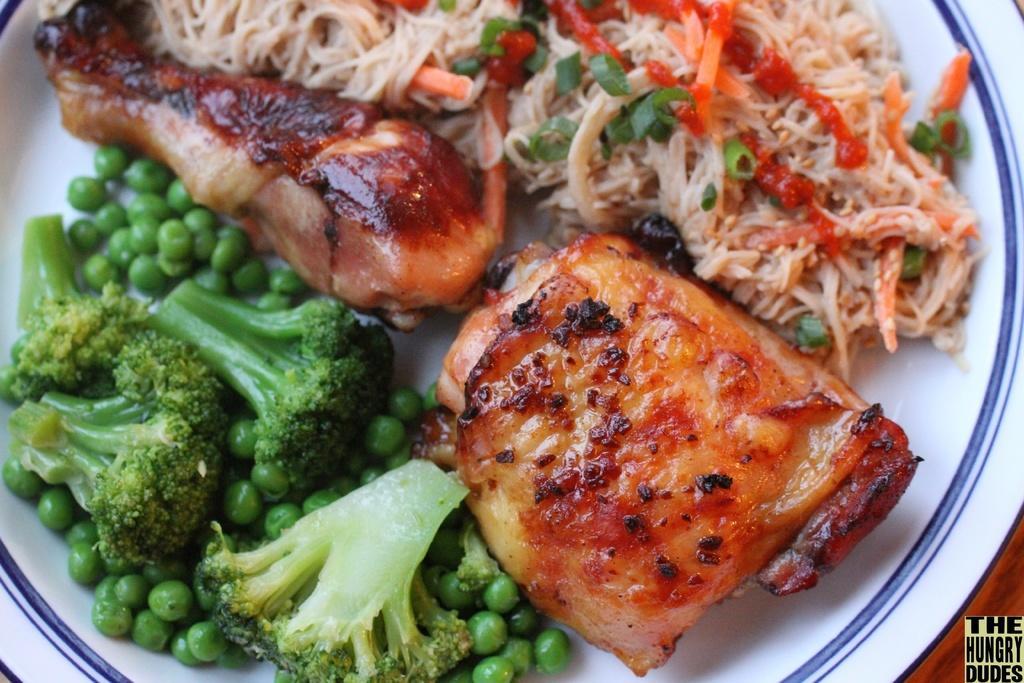Could you give a brief overview of what you see in this image? In this image there is a plate with delicious food which contains broccoli, green peas, chicken leg piece and noodles. 